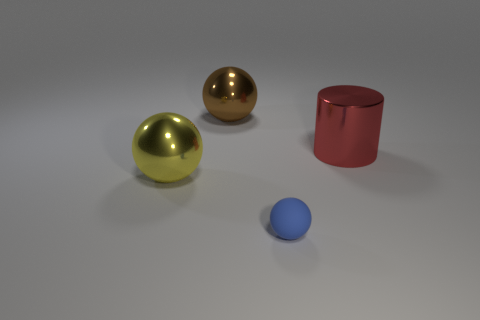Are there any other things that have the same size as the rubber thing?
Ensure brevity in your answer.  No. What color is the rubber object?
Your answer should be very brief. Blue. There is a cylinder that is made of the same material as the brown object; what is its size?
Your response must be concise. Large. The cylinder that is the same material as the yellow object is what color?
Give a very brief answer. Red. Are there any cylinders that have the same size as the yellow ball?
Make the answer very short. Yes. There is a big brown object that is the same shape as the tiny blue thing; what is its material?
Your response must be concise. Metal. What is the shape of the brown metallic thing that is the same size as the yellow sphere?
Provide a succinct answer. Sphere. Are there any yellow metallic objects of the same shape as the large brown shiny thing?
Your answer should be very brief. Yes. There is a tiny object that is right of the large yellow object to the left of the big brown sphere; what shape is it?
Provide a short and direct response. Sphere. What is the shape of the brown thing?
Your answer should be very brief. Sphere. 